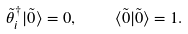<formula> <loc_0><loc_0><loc_500><loc_500>\tilde { \theta } _ { i } ^ { \dag } | \tilde { 0 } \rangle = 0 , \quad \langle \tilde { 0 } | \tilde { 0 } \rangle = 1 .</formula> 